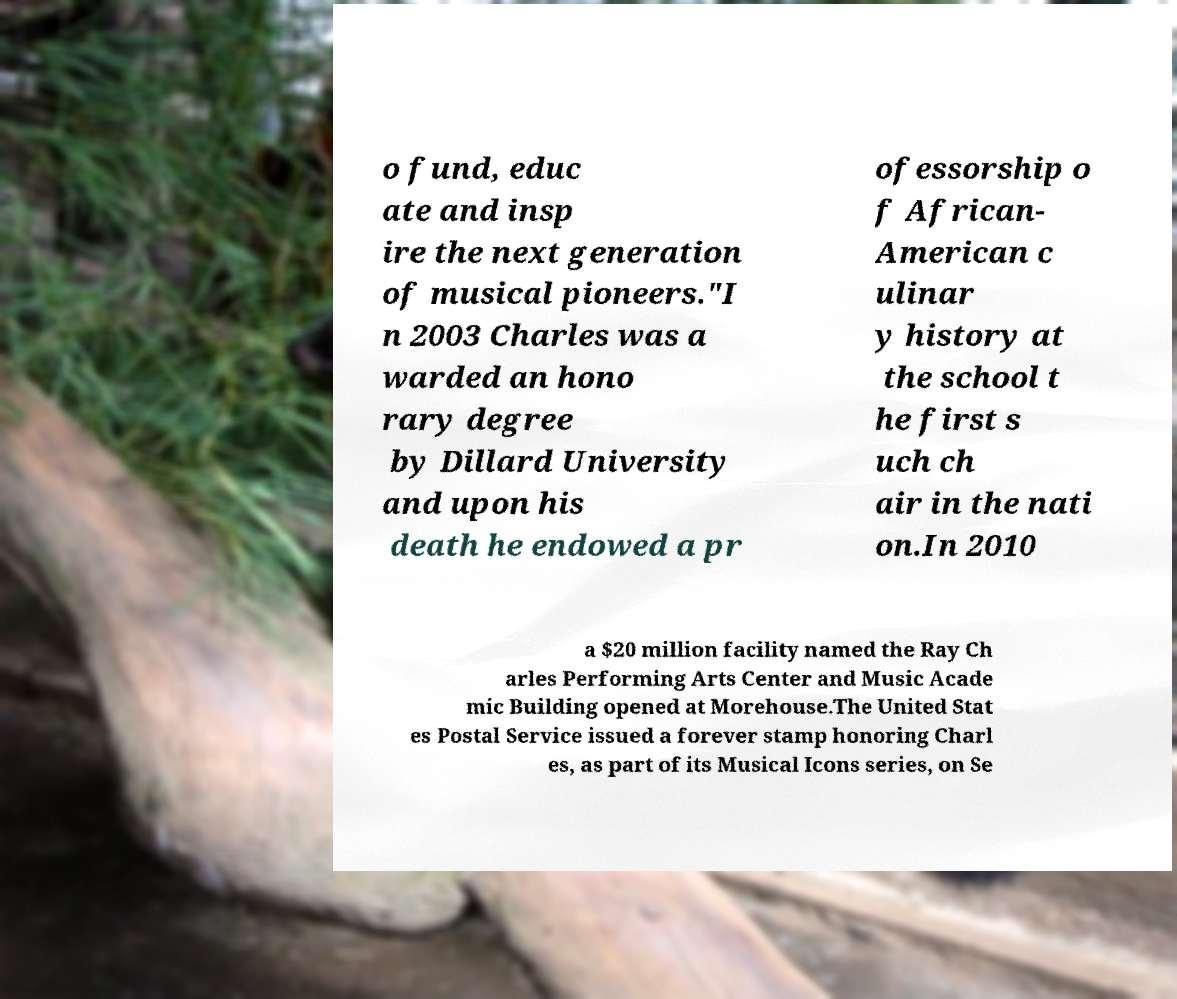There's text embedded in this image that I need extracted. Can you transcribe it verbatim? o fund, educ ate and insp ire the next generation of musical pioneers."I n 2003 Charles was a warded an hono rary degree by Dillard University and upon his death he endowed a pr ofessorship o f African- American c ulinar y history at the school t he first s uch ch air in the nati on.In 2010 a $20 million facility named the Ray Ch arles Performing Arts Center and Music Acade mic Building opened at Morehouse.The United Stat es Postal Service issued a forever stamp honoring Charl es, as part of its Musical Icons series, on Se 